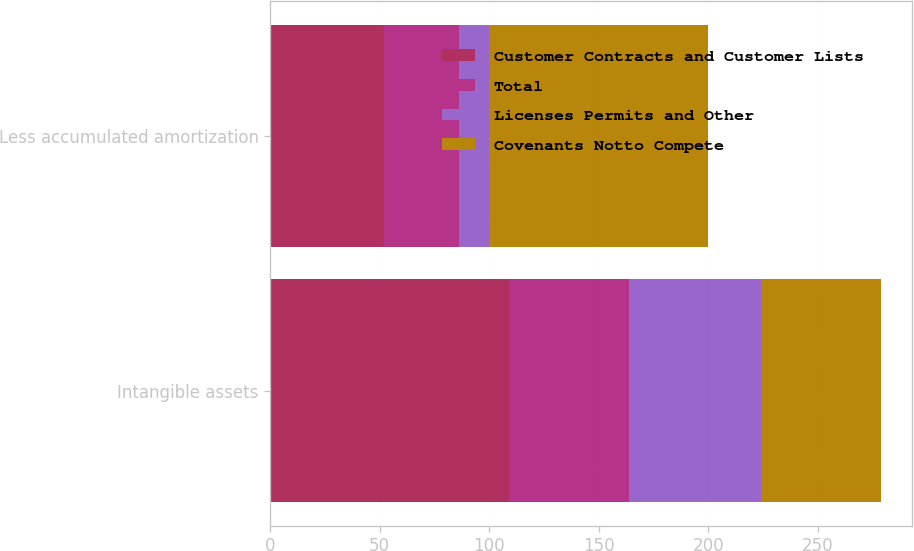<chart> <loc_0><loc_0><loc_500><loc_500><stacked_bar_chart><ecel><fcel>Intangible assets<fcel>Less accumulated amortization<nl><fcel>Customer Contracts and Customer Lists<fcel>109<fcel>52<nl><fcel>Total<fcel>55<fcel>34<nl><fcel>Licenses Permits and Other<fcel>60<fcel>14<nl><fcel>Covenants Notto Compete<fcel>55<fcel>100<nl></chart> 